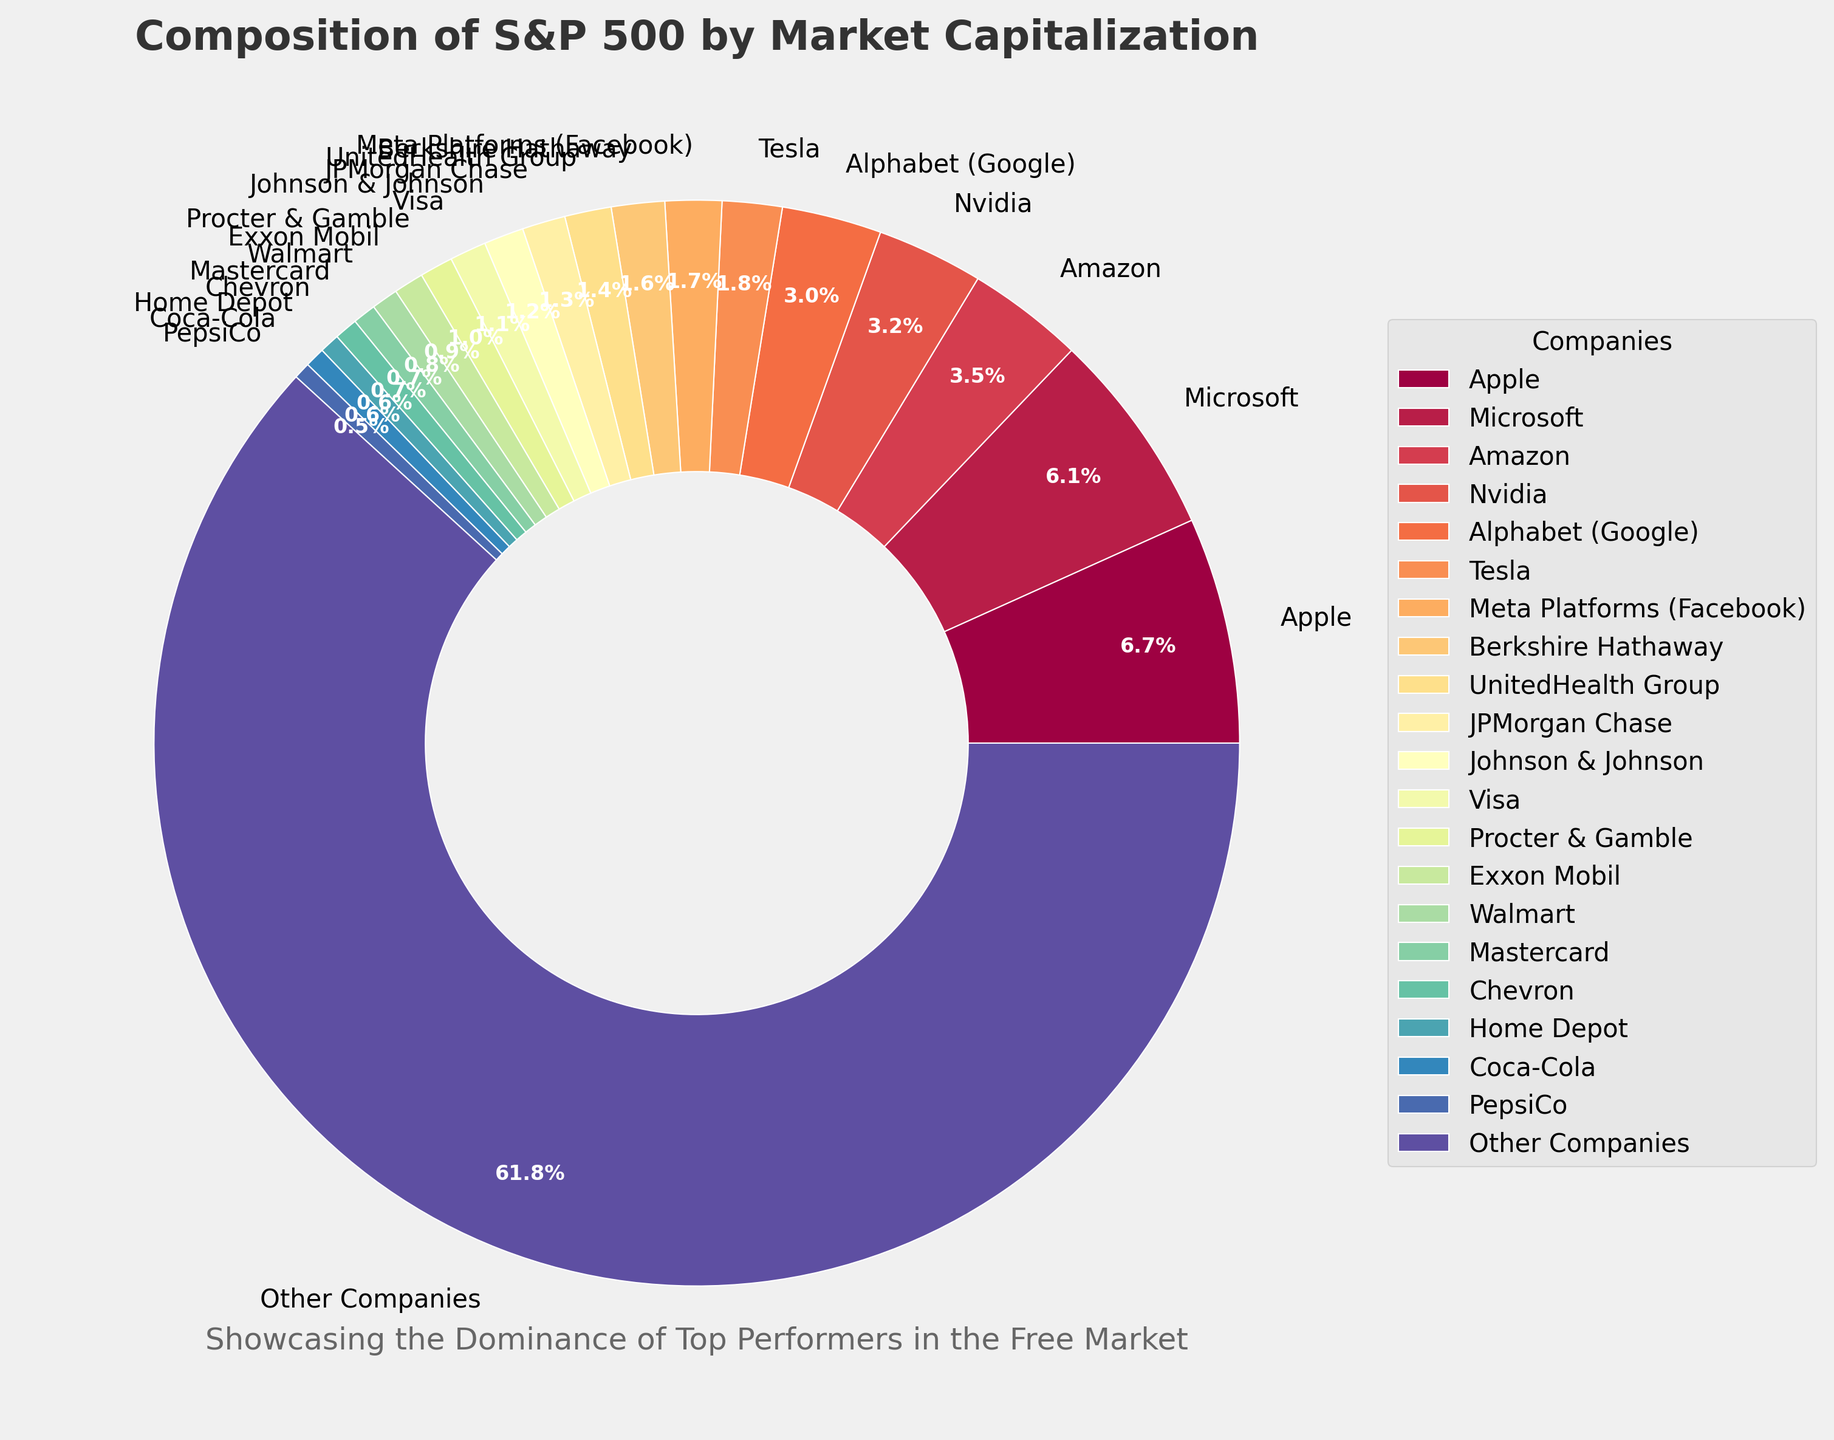Which company holds the largest market cap percentage in the S&P 500 index? The pie chart shows different market cap percentages for each company. By simply looking at the sectors, Apple has the largest market cap at 6.8%.
Answer: Apple What is the combined market cap percentage of the top 3 companies? Adding the market cap percentages of Apple (6.8%), Microsoft (6.2%), and Amazon (3.5%) gives a combined percentage of 6.8 + 6.2 + 3.5 = 16.5%.
Answer: 16.5% Which company has a higher market cap percentage, Nvidia or Alphabet (Google)? By looking at the labels on the pie chart, Nvidia has a market cap percentage of 3.2%, while Alphabet (Google) has 3.0%. Hence, Nvidia has a higher market cap percentage.
Answer: Nvidia How does Tesla's market cap percentage compare to Meta Platforms (Facebook)? Tesla holds a market cap percentage of 1.8% while Meta Platforms (Facebook) holds 1.7%. Tesla's percentage is slightly higher.
Answer: Tesla What is the market cap percentage of companies classified as "Other Companies"? The sector labeled "Other Companies" has a market cap percentage of 62.4%, which is indicated in the pie chart.
Answer: 62.4% What share of market cap percentage do Berkshire Hathaway and UnitedHealth Group have together? Berkshire Hathaway has a market cap percentage of 1.6% and UnitedHealth Group has 1.4%. Adding them together gives 1.6 + 1.4 = 3.0%.
Answer: 3.0% How does the market cap percentage of Exxon Mobil compare to Walmart? By referring to the pie chart, Exxon Mobil's market cap percentage is 0.9%, and Walmart's is 0.8%. Therefore, Exxon Mobil's percentage is higher by 0.1%.
Answer: Exxon Mobil Which company has a market cap percentage closest to 1%? The pie chart indicates that Procter & Gamble has a market cap percentage of exactly 1.0%.
Answer: Procter & Gamble What is the total market cap percentage of the financial sector companies listed (JPMorgan Chase, Visa, Mastercard, Berkshire Hathaway)? Summing the percentages for the financial sector companies listed: JPMorgan Chase (1.3%), Visa (1.1%), Mastercard (0.7%), Berkshire Hathaway (1.6%) results in 1.3 + 1.1 + 0.7 + 1.6 = 4.7%.
Answer: 4.7% Which company has the lowest market cap percentage among the listed top companies, excluding "Other Companies"? Referring to the pie chart, PepsiCo holds the lowest market cap percentage among the listed companies at 0.5%.
Answer: PepsiCo 